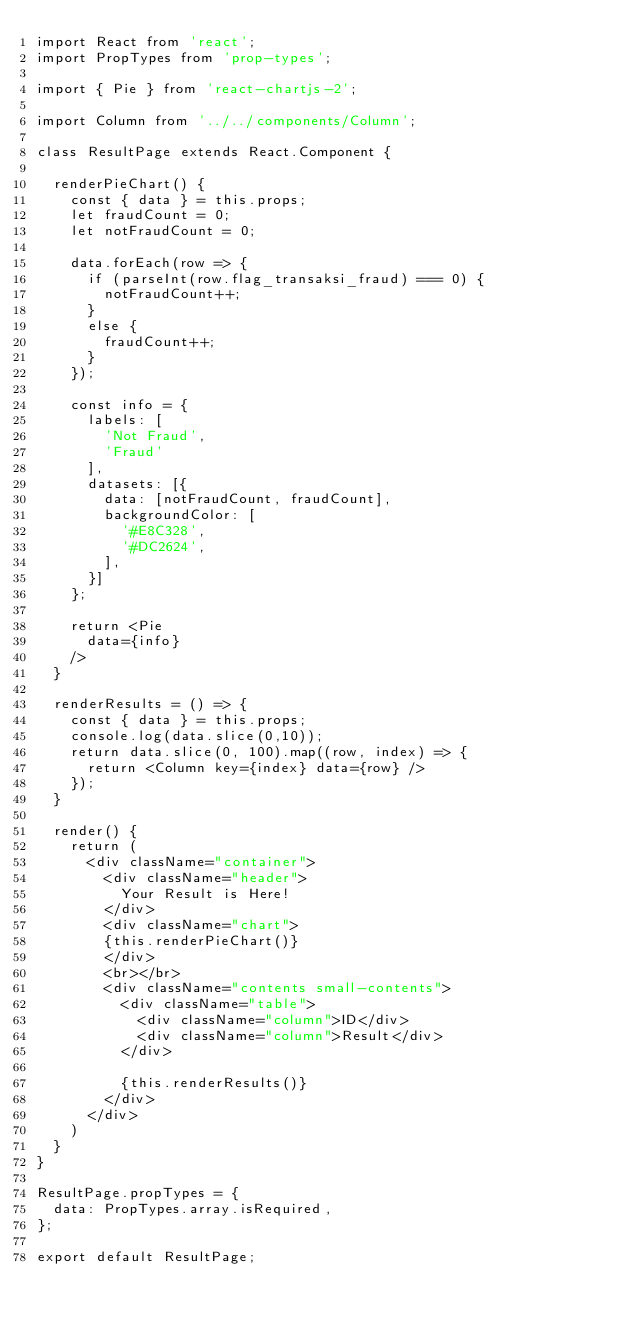<code> <loc_0><loc_0><loc_500><loc_500><_JavaScript_>import React from 'react';
import PropTypes from 'prop-types';

import { Pie } from 'react-chartjs-2';

import Column from '../../components/Column';

class ResultPage extends React.Component {

  renderPieChart() {
    const { data } = this.props;
    let fraudCount = 0;
    let notFraudCount = 0;

    data.forEach(row => {
      if (parseInt(row.flag_transaksi_fraud) === 0) {
        notFraudCount++;
      }
      else {
        fraudCount++;
      }
    });

    const info = {
      labels: [
        'Not Fraud',
        'Fraud'
      ],
      datasets: [{
        data: [notFraudCount, fraudCount],
        backgroundColor: [
          '#E8C328',
          '#DC2624',
        ],
      }]
    };

    return <Pie 
      data={info}
    />
  }

  renderResults = () => {
    const { data } = this.props;
    console.log(data.slice(0,10));
    return data.slice(0, 100).map((row, index) => {
      return <Column key={index} data={row} />
    });
  }
  
  render() {
    return (
      <div className="container">
        <div className="header">
          Your Result is Here!
        </div>
        <div className="chart">
        {this.renderPieChart()}
        </div>
        <br></br>
        <div className="contents small-contents">
          <div className="table">
            <div className="column">ID</div>
            <div className="column">Result</div>
          </div>
          
          {this.renderResults()}
        </div>
      </div>
    )
  }
}

ResultPage.propTypes = {
  data: PropTypes.array.isRequired,
};

export default ResultPage;
</code> 